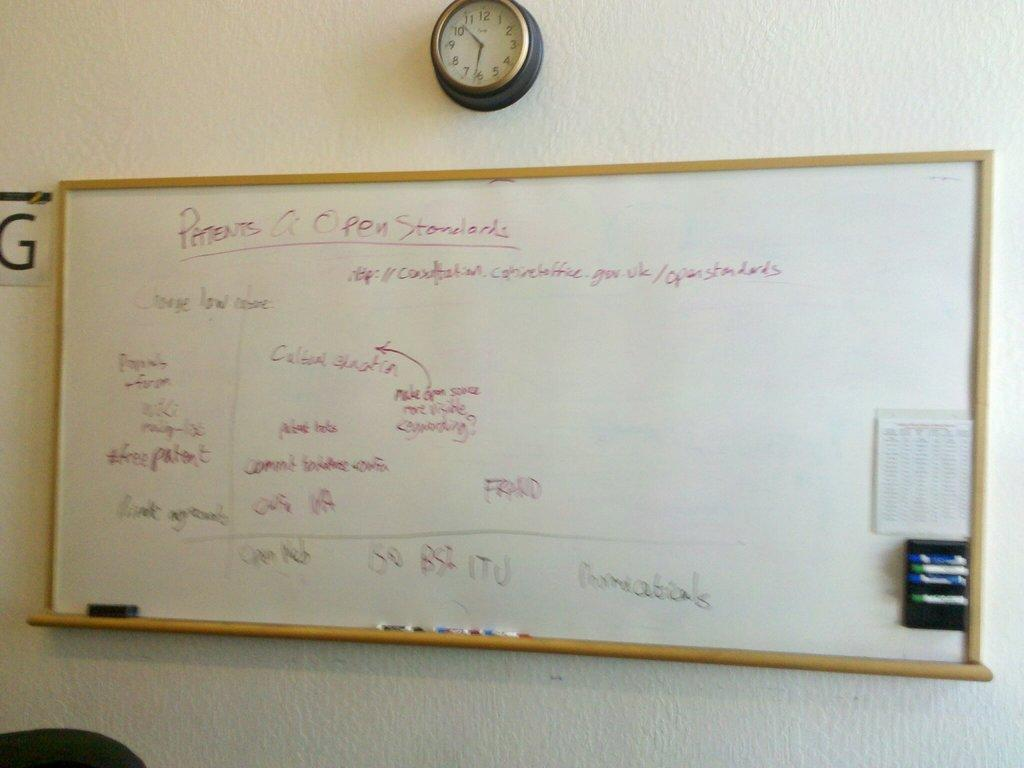Provide a one-sentence caption for the provided image. a patents name that is on a white board. 